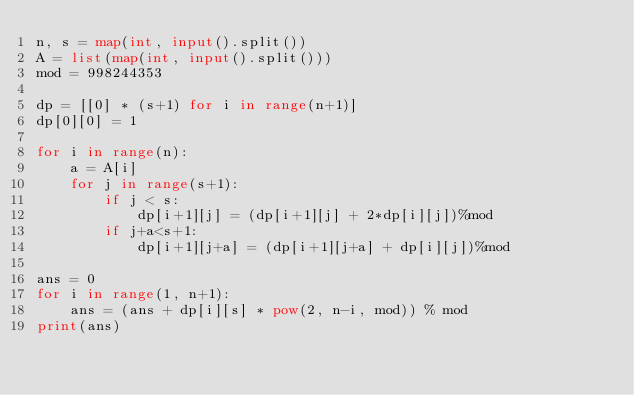Convert code to text. <code><loc_0><loc_0><loc_500><loc_500><_Python_>n, s = map(int, input().split())
A = list(map(int, input().split()))
mod = 998244353

dp = [[0] * (s+1) for i in range(n+1)]
dp[0][0] = 1

for i in range(n):
    a = A[i]
    for j in range(s+1):
        if j < s:
            dp[i+1][j] = (dp[i+1][j] + 2*dp[i][j])%mod
        if j+a<s+1:
            dp[i+1][j+a] = (dp[i+1][j+a] + dp[i][j])%mod

ans = 0
for i in range(1, n+1):
    ans = (ans + dp[i][s] * pow(2, n-i, mod)) % mod
print(ans)


</code> 